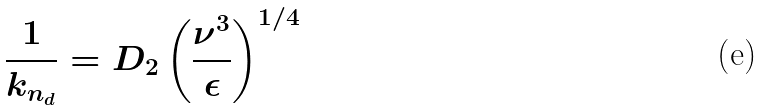Convert formula to latex. <formula><loc_0><loc_0><loc_500><loc_500>\frac { 1 } { k _ { n _ { d } } } = D _ { 2 } \left ( \frac { \nu ^ { 3 } } { \epsilon } \right ) ^ { 1 / 4 }</formula> 